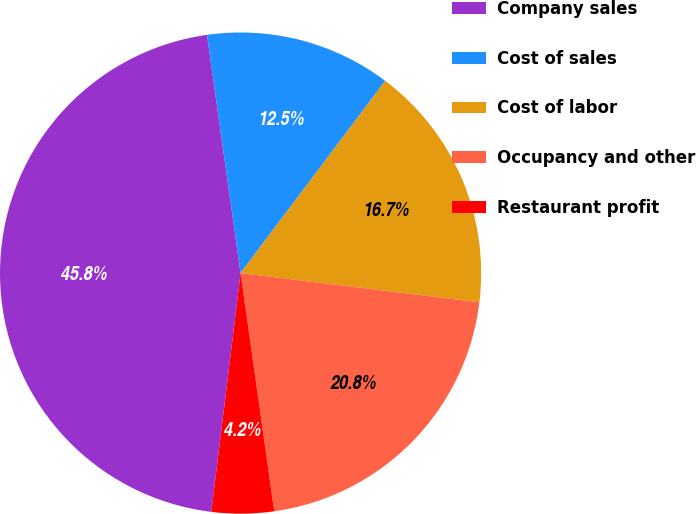<chart> <loc_0><loc_0><loc_500><loc_500><pie_chart><fcel>Company sales<fcel>Cost of sales<fcel>Cost of labor<fcel>Occupancy and other<fcel>Restaurant profit<nl><fcel>45.83%<fcel>12.5%<fcel>16.67%<fcel>20.83%<fcel>4.17%<nl></chart> 